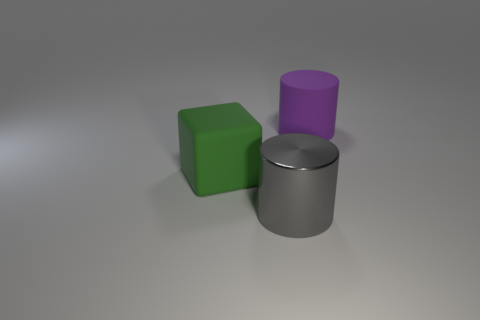What is the material of the object that is right of the large gray object?
Give a very brief answer. Rubber. Is the number of large gray metal cylinders behind the big purple cylinder less than the number of big yellow shiny blocks?
Offer a very short reply. No. There is a gray shiny object that is to the left of the big cylinder that is behind the metal cylinder; what shape is it?
Provide a succinct answer. Cylinder. The rubber cube has what color?
Your answer should be compact. Green. What number of other objects are the same size as the cube?
Give a very brief answer. 2. There is a large thing that is to the right of the green thing and behind the big gray cylinder; what material is it made of?
Give a very brief answer. Rubber. There is a thing that is behind the block; is it the same size as the block?
Make the answer very short. Yes. Is the metallic cylinder the same color as the large rubber block?
Provide a succinct answer. No. How many big things are both behind the green rubber object and on the left side of the large gray metal cylinder?
Your response must be concise. 0. How many blocks are to the right of the big matte thing that is right of the large cylinder in front of the large green block?
Offer a very short reply. 0. 